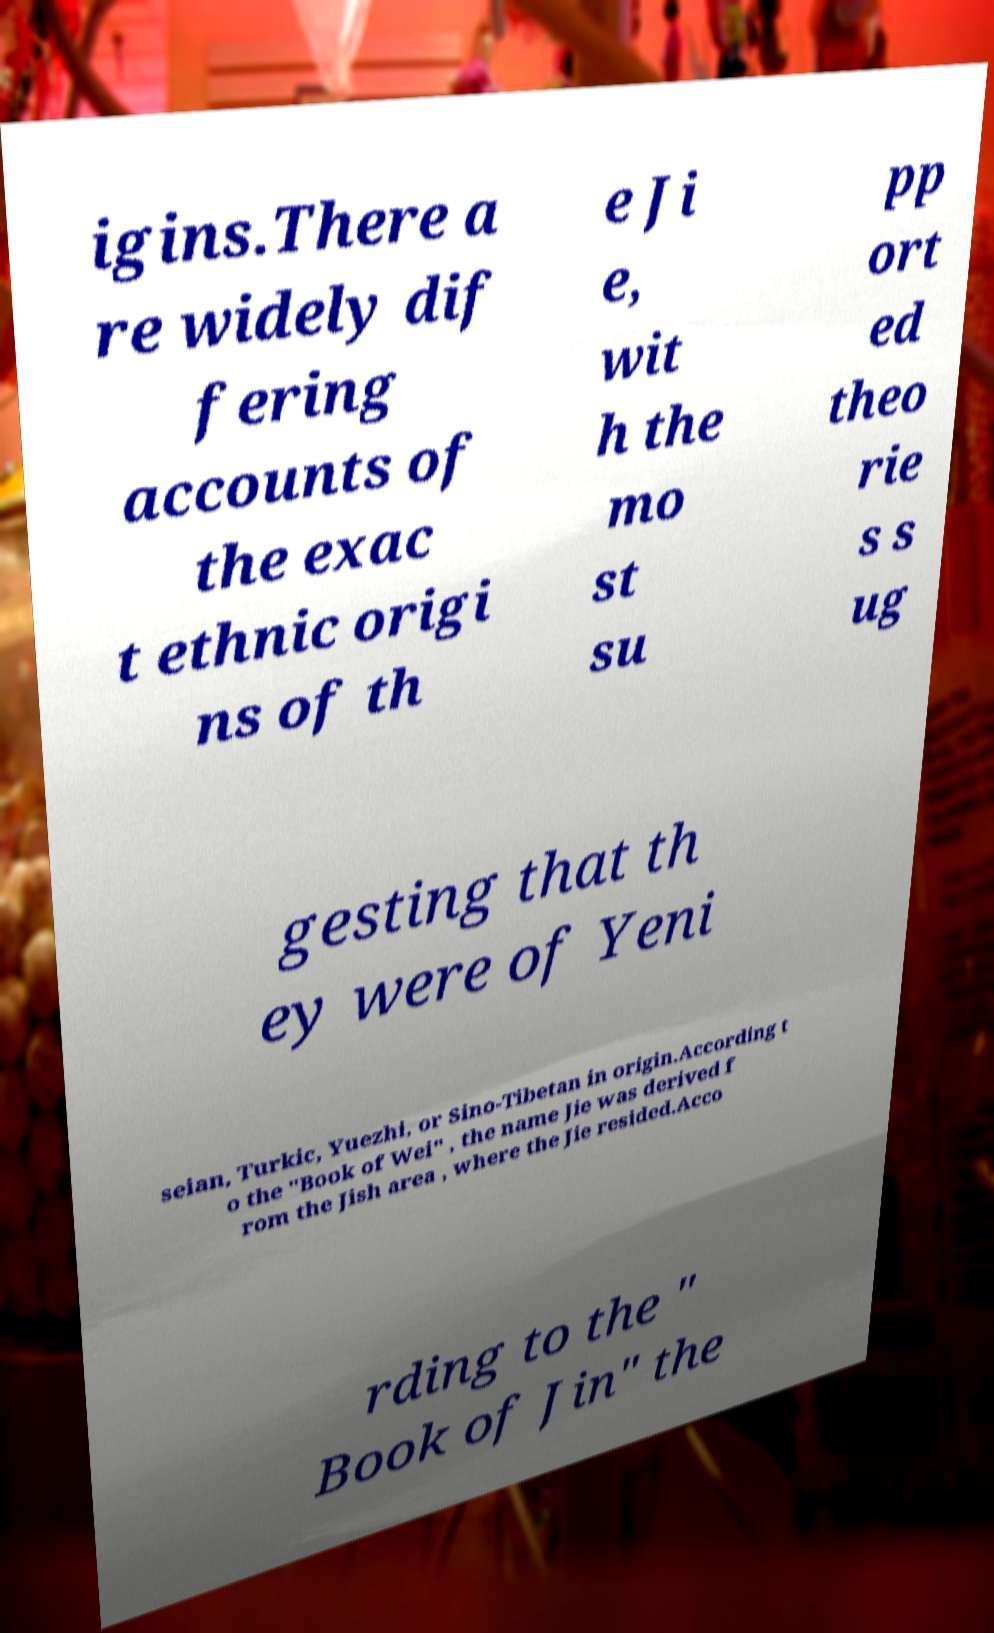Please read and relay the text visible in this image. What does it say? igins.There a re widely dif fering accounts of the exac t ethnic origi ns of th e Ji e, wit h the mo st su pp ort ed theo rie s s ug gesting that th ey were of Yeni seian, Turkic, Yuezhi, or Sino-Tibetan in origin.According t o the "Book of Wei" , the name Jie was derived f rom the Jish area , where the Jie resided.Acco rding to the " Book of Jin" the 